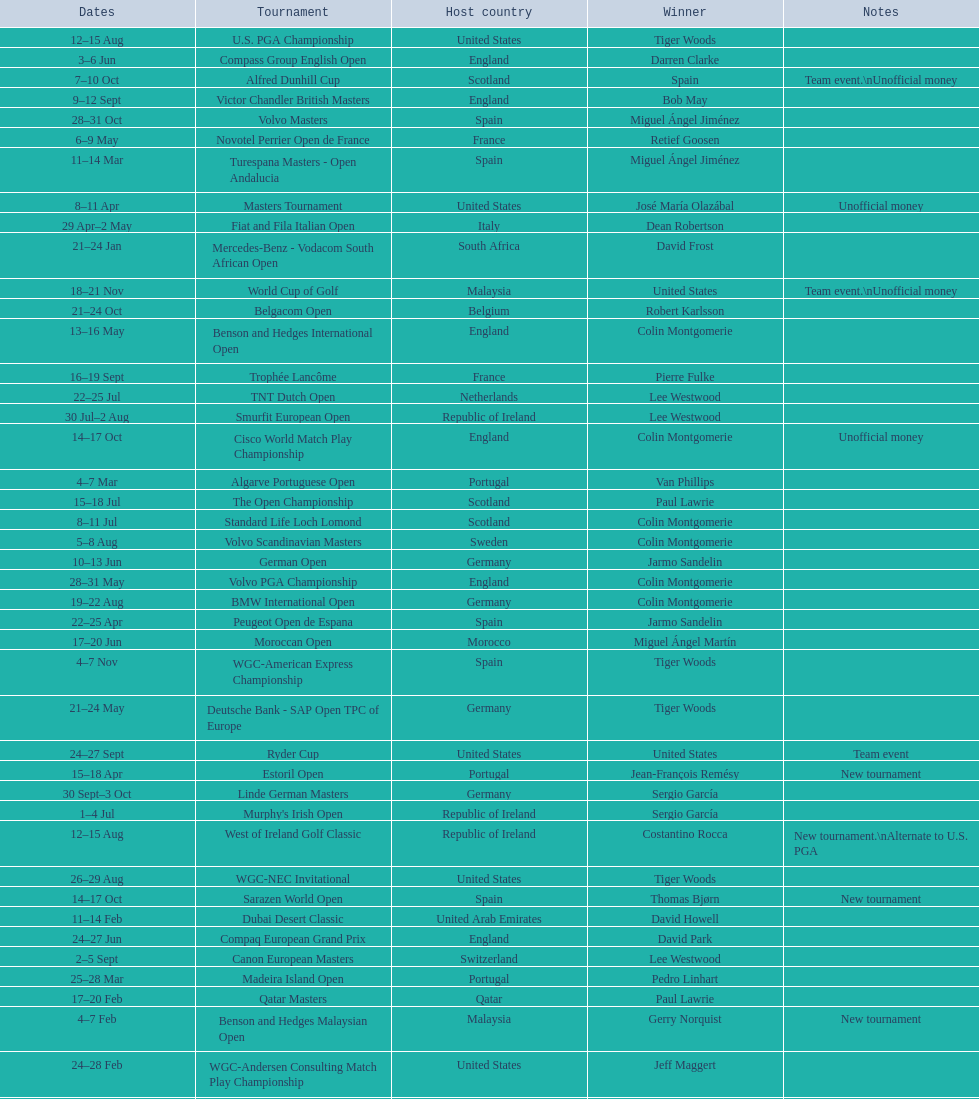Which tournament was later, volvo pga or algarve portuguese open? Volvo PGA. 